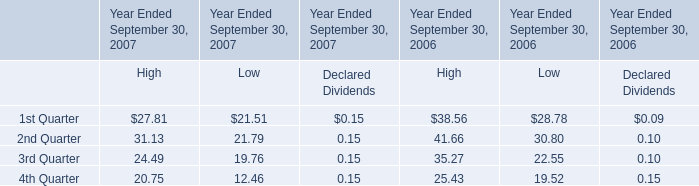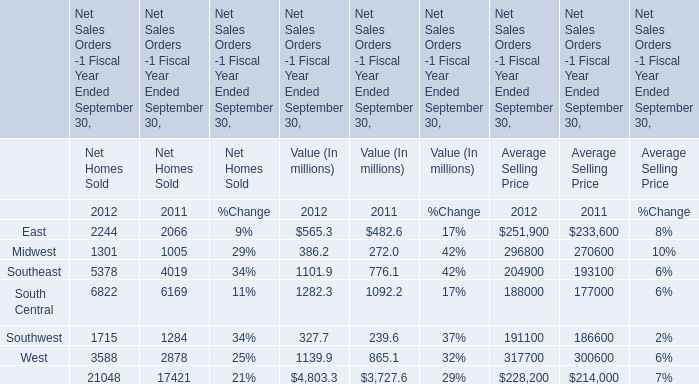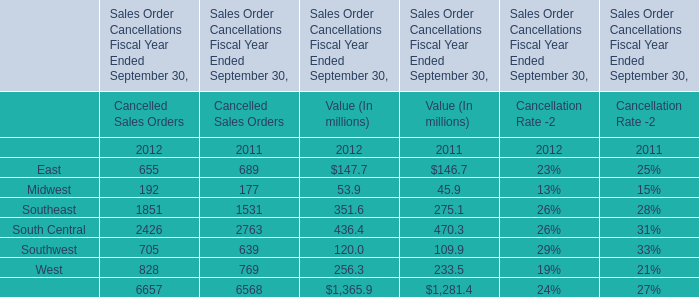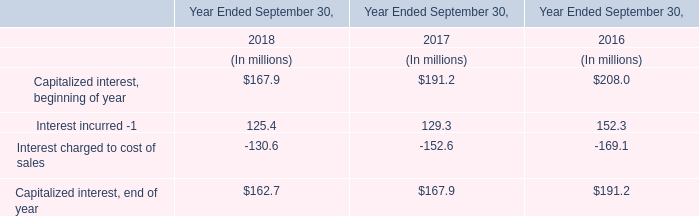If Midwest develops with the same growth rate in 2012, what will it reach in 2013? (in million) 
Computations: ((((386.2 - 272.0) / 272.0) + 1) * 386.2)
Answer: 548.34721. 